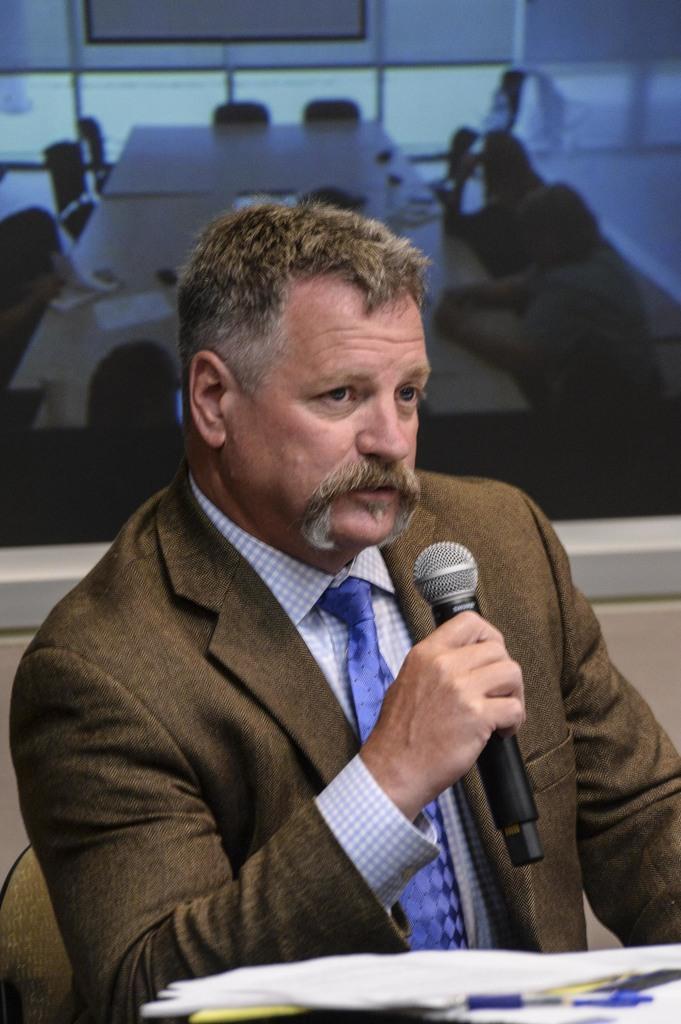Describe this image in one or two sentences. In this image I can see a man is sitting hand holding a mic, I can see he is wearing blazer, shirt and tie. Here I can see few papers and a pen. In the background I can see few more chairs and tables. 